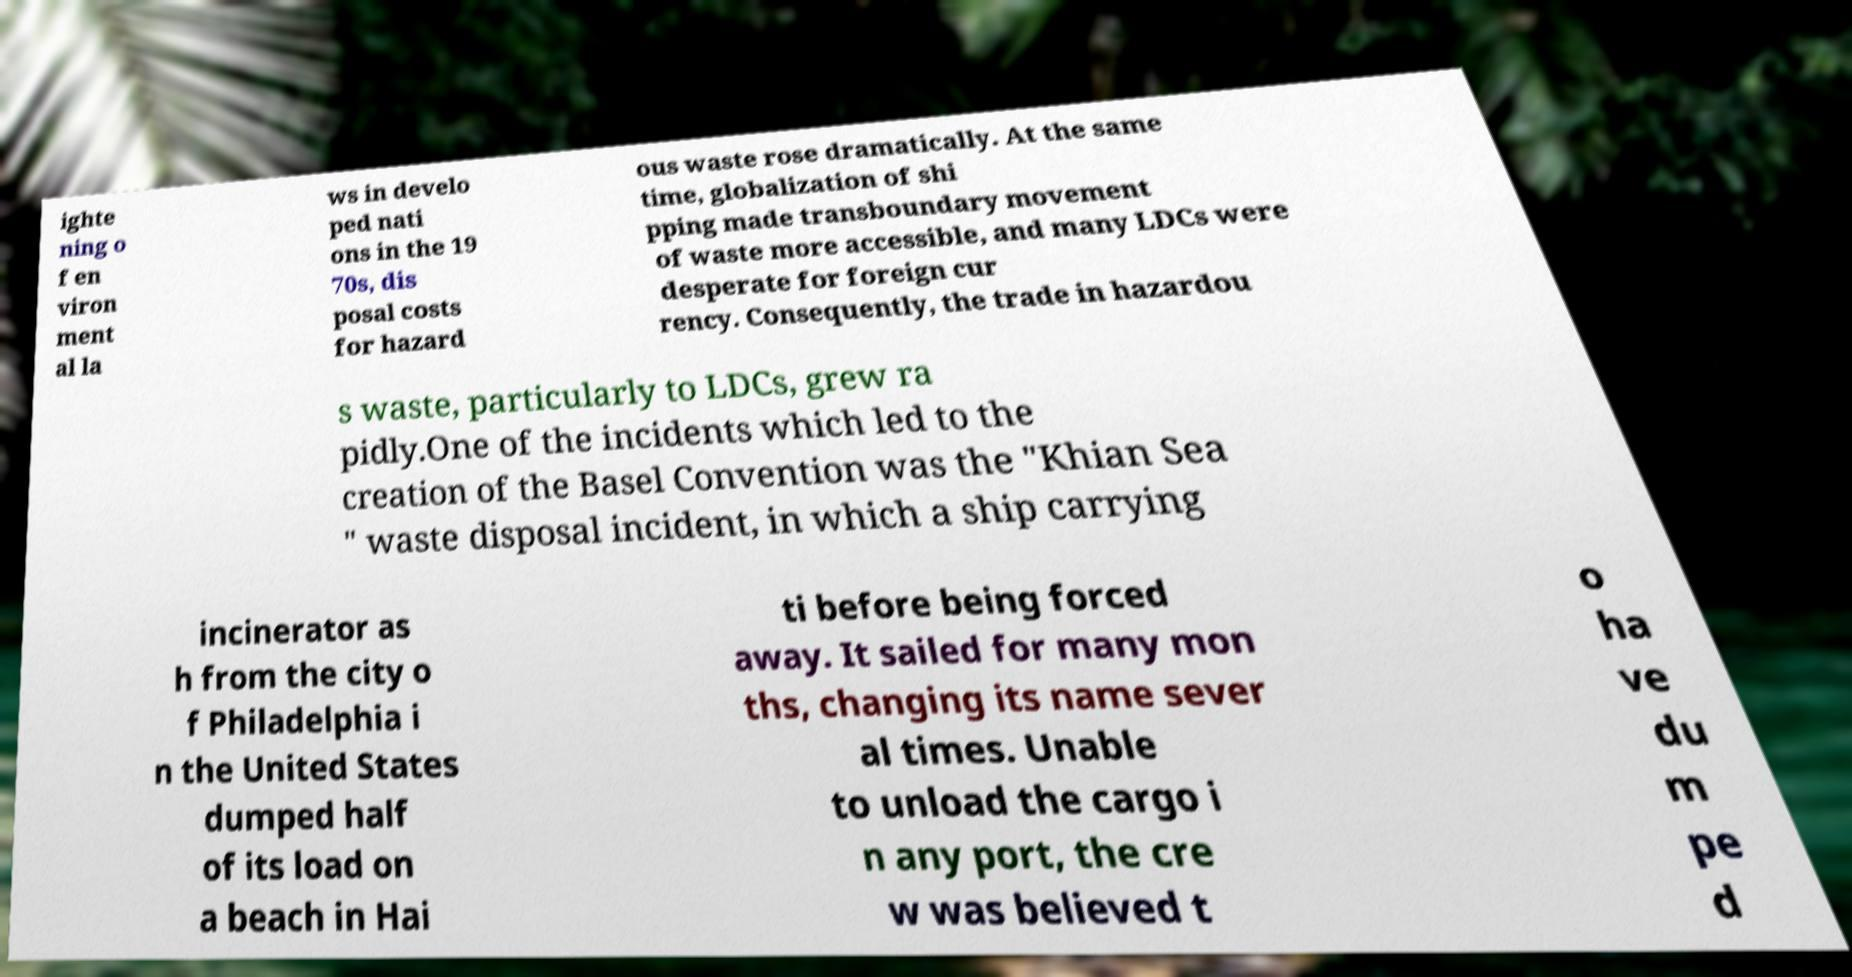Could you assist in decoding the text presented in this image and type it out clearly? ighte ning o f en viron ment al la ws in develo ped nati ons in the 19 70s, dis posal costs for hazard ous waste rose dramatically. At the same time, globalization of shi pping made transboundary movement of waste more accessible, and many LDCs were desperate for foreign cur rency. Consequently, the trade in hazardou s waste, particularly to LDCs, grew ra pidly.One of the incidents which led to the creation of the Basel Convention was the "Khian Sea " waste disposal incident, in which a ship carrying incinerator as h from the city o f Philadelphia i n the United States dumped half of its load on a beach in Hai ti before being forced away. It sailed for many mon ths, changing its name sever al times. Unable to unload the cargo i n any port, the cre w was believed t o ha ve du m pe d 